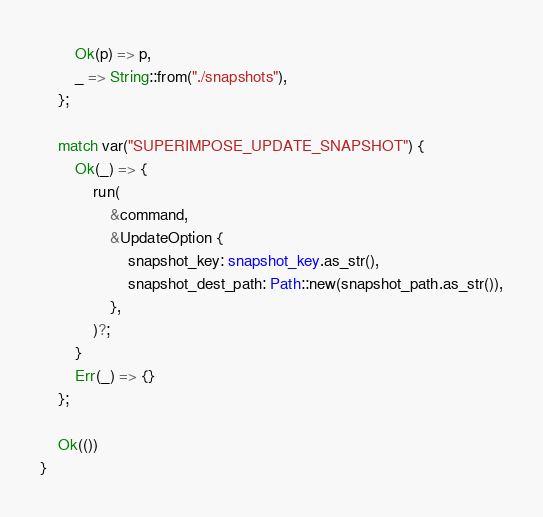<code> <loc_0><loc_0><loc_500><loc_500><_Rust_>        Ok(p) => p,
        _ => String::from("./snapshots"),
    };

    match var("SUPERIMPOSE_UPDATE_SNAPSHOT") {
        Ok(_) => {
            run(
                &command,
                &UpdateOption {
                    snapshot_key: snapshot_key.as_str(),
                    snapshot_dest_path: Path::new(snapshot_path.as_str()),
                },
            )?;
        }
        Err(_) => {}
    };

    Ok(())
}
</code> 